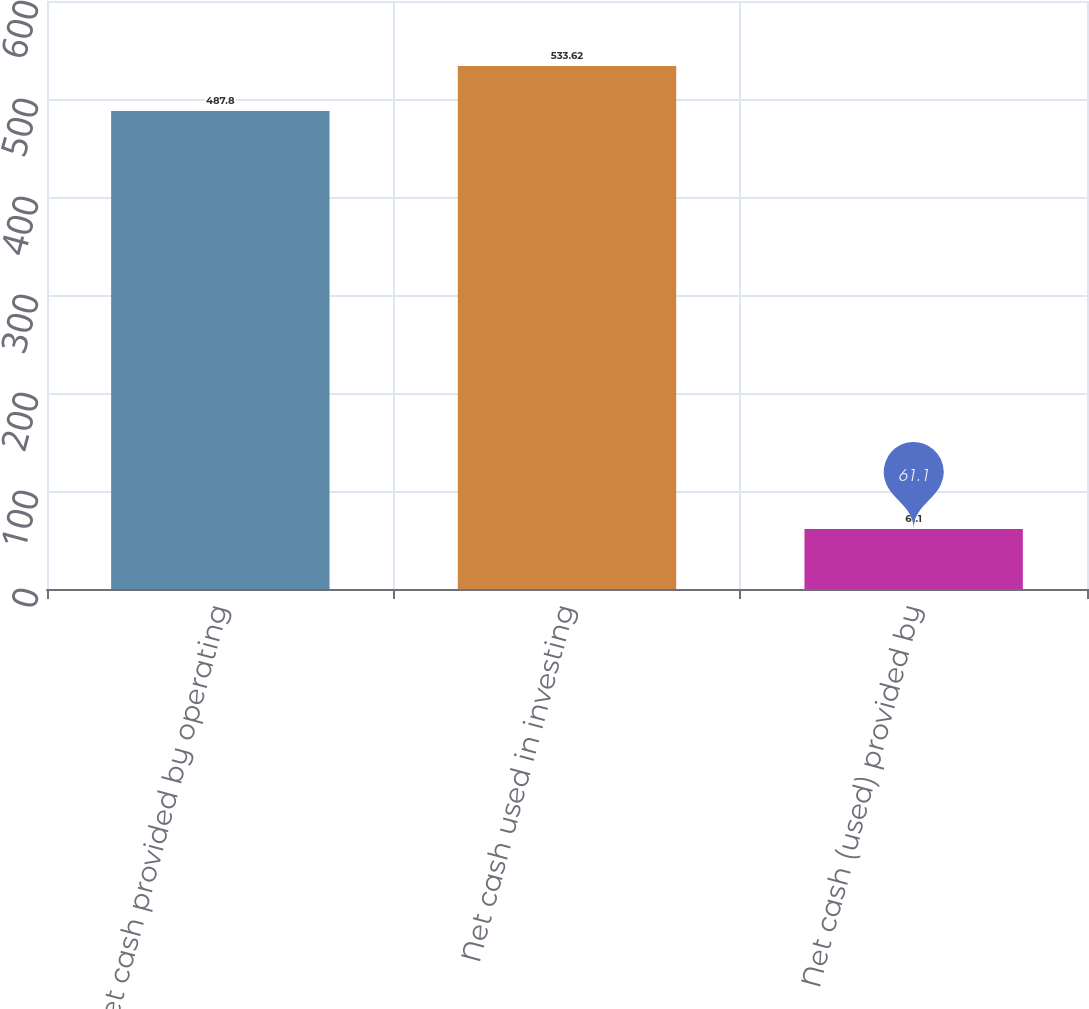Convert chart to OTSL. <chart><loc_0><loc_0><loc_500><loc_500><bar_chart><fcel>Net cash provided by operating<fcel>Net cash used in investing<fcel>Net cash (used) provided by<nl><fcel>487.8<fcel>533.62<fcel>61.1<nl></chart> 